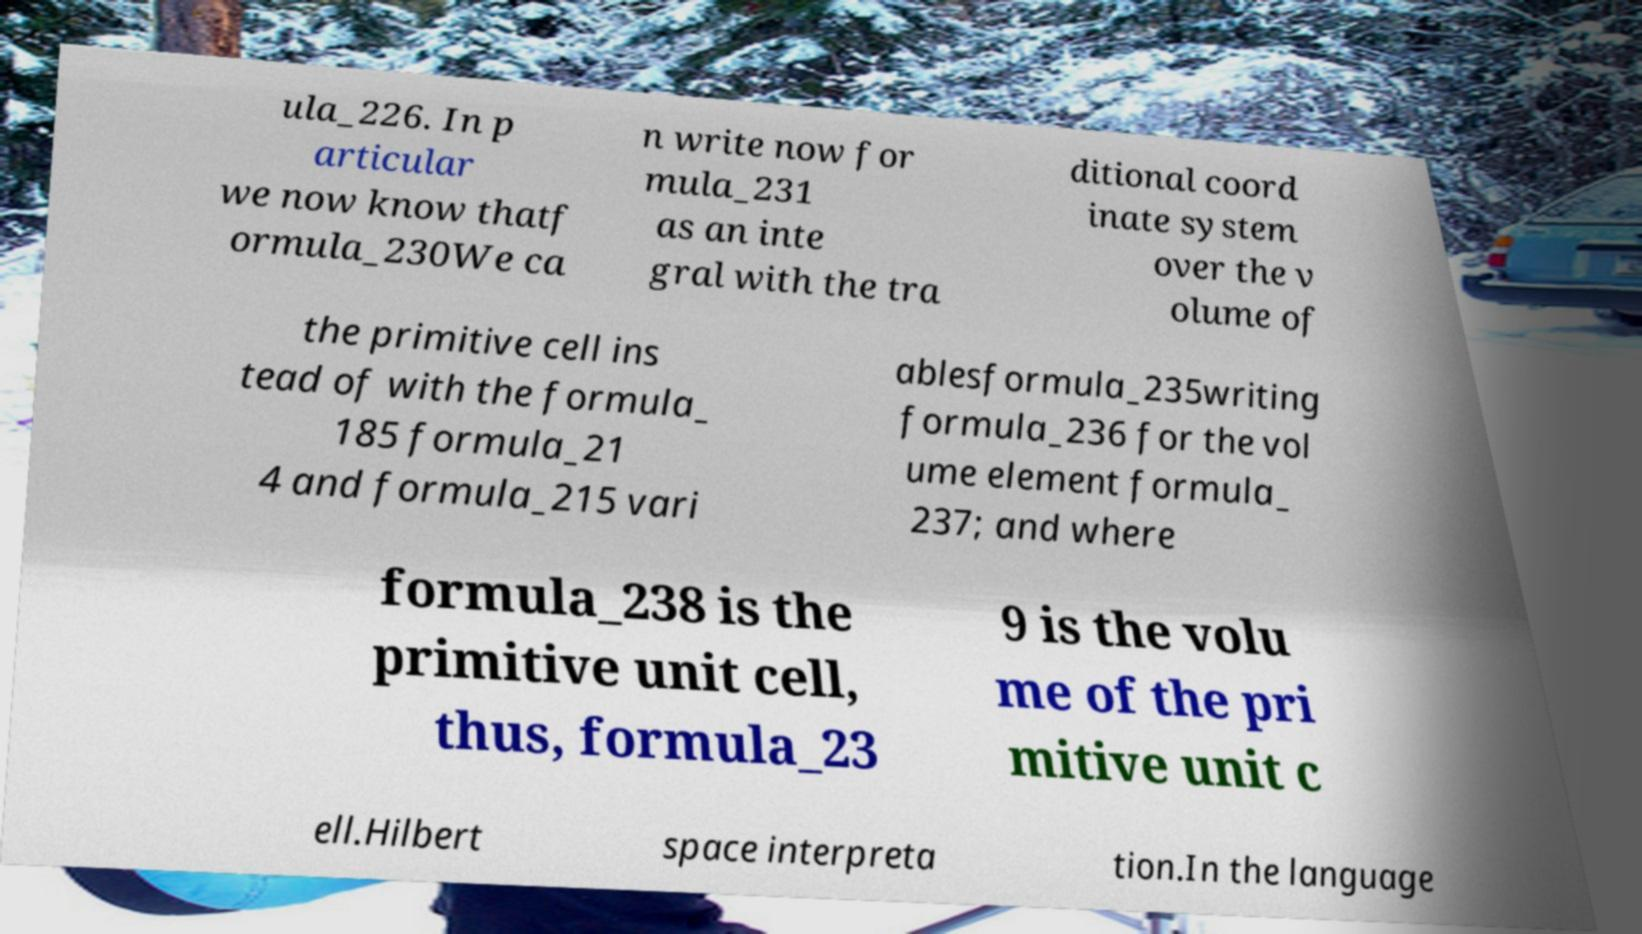Can you read and provide the text displayed in the image?This photo seems to have some interesting text. Can you extract and type it out for me? ula_226. In p articular we now know thatf ormula_230We ca n write now for mula_231 as an inte gral with the tra ditional coord inate system over the v olume of the primitive cell ins tead of with the formula_ 185 formula_21 4 and formula_215 vari ablesformula_235writing formula_236 for the vol ume element formula_ 237; and where formula_238 is the primitive unit cell, thus, formula_23 9 is the volu me of the pri mitive unit c ell.Hilbert space interpreta tion.In the language 